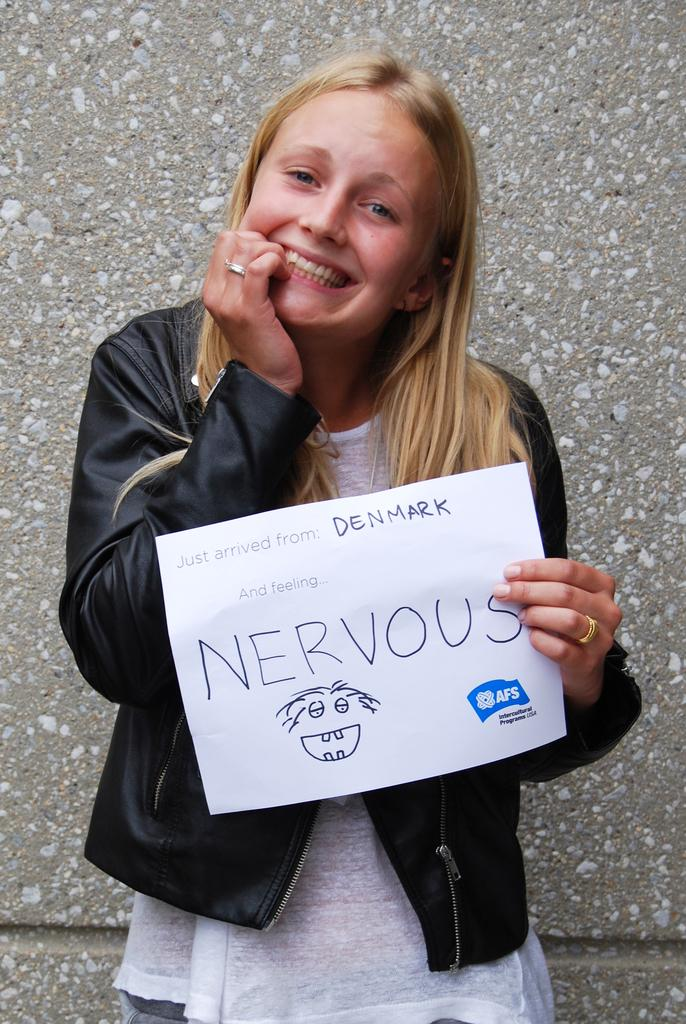Who is the main subject in the image? There is a lady in the image. What is the lady wearing? The lady is wearing a jacket. What is the lady holding in the image? The lady is holding a paper. Can you describe the paper? There is writing on the paper. What type of bottle is visible in the image? There is no bottle present in the image. Can you describe the picture on the wall in the image? There is no picture on the wall mentioned in the provided facts, so we cannot describe it. 